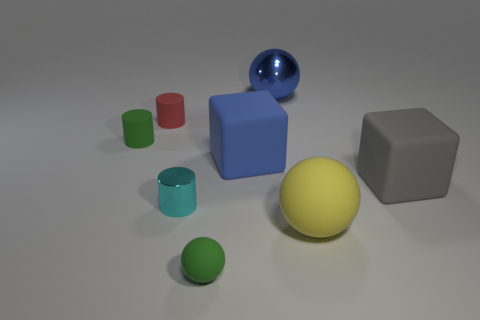Add 1 large gray rubber blocks. How many objects exist? 9 Subtract all green matte balls. How many balls are left? 2 Subtract 2 cubes. How many cubes are left? 0 Subtract all cyan cylinders. How many cylinders are left? 2 Subtract all blocks. How many objects are left? 6 Add 1 red objects. How many red objects are left? 2 Add 7 small red matte things. How many small red matte things exist? 8 Subtract 1 green cylinders. How many objects are left? 7 Subtract all gray cubes. Subtract all gray cylinders. How many cubes are left? 1 Subtract all yellow matte things. Subtract all tiny gray metal cylinders. How many objects are left? 7 